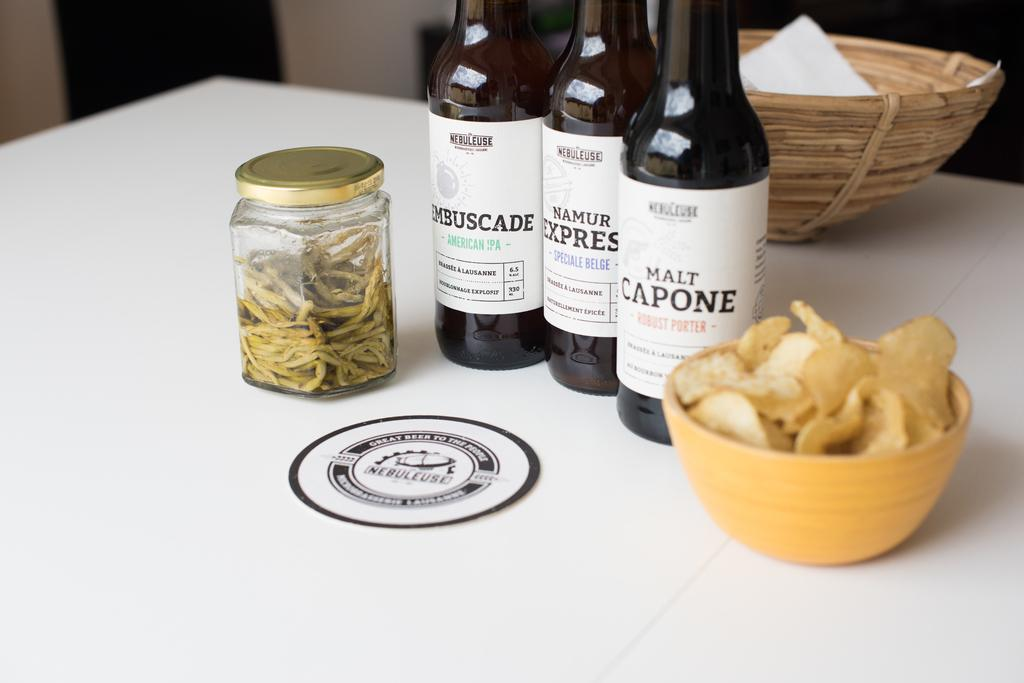How many bottles are visible in the image? There are three bottles in the image. What other container can be seen in the image besides the bottles? There is a jar in the image. What type of snack is in the bowl in the image? There is a bowl with chips in the image. What is the purpose of the basket in the image? The purpose of the basket in the image is not clear, but it is likely used for holding or organizing items. Where are all these objects located in the image? All of these objects are on a table in the image. What time of day is it in the image, considering the morning light? The image does not provide any information about the time of day, and there is no mention of morning light. 